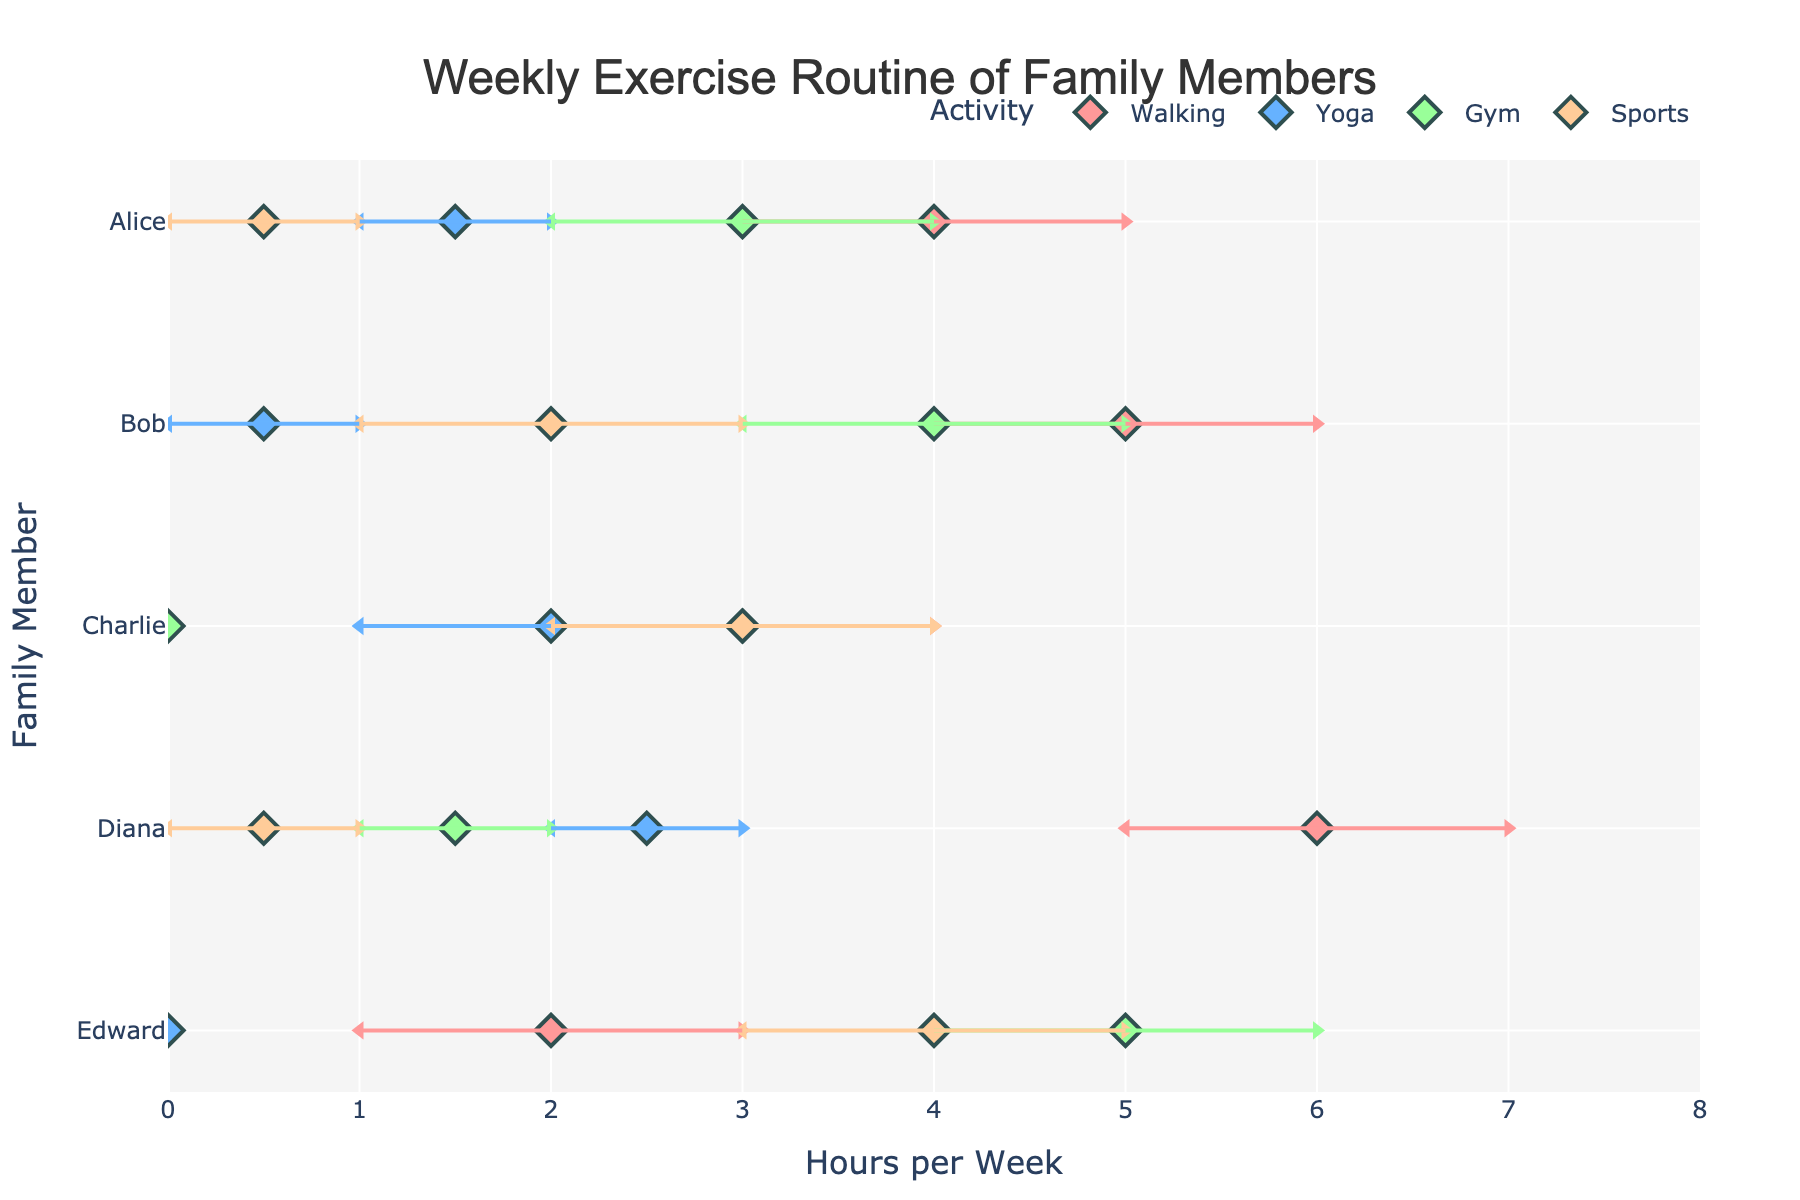What is the title of the figure? The title of the figure is generally displayed at the top center of the plot in a larger font size. It summarizes the contents of the plot.
Answer: Weekly Exercise Routine of Family Members Which family member spends the most hours walking? Look for the family member with the highest value in the range for the "Walking" activity. This means comparing the maximum hours for walking among all family members.
Answer: Diana Who spends more time on sports, Charlie or Edward? Compare the ranges of hours spent on sports for Charlie and Edward. Charlie's range is 2 to 4 hours, while Edward's range is 3 to 5 hours. Edward has a higher range.
Answer: Edward What is the minimum number of hours per week that Diana spends on yoga? Look at Diana's data for the yoga activity and find the minimum value in the given range.
Answer: 2 Which activity is marked with a blue color? Notice the colors used to represent different activities in the plot's legend. Identify which activity corresponds to the blue color.
Answer: Yoga How many activities does Alice participate in? Count the number of distinct activities listed for Alice in the data table.
Answer: 4 Which activities does Edward not participate in? Check Edward's details for activities that have either 0 hours in both min and max columns or are not listed.
Answer: Yoga Who has the highest maximum number of hours for any single activity? Identify the highest maximum hour value among all activities for all family members. Compare these maximum values to find the highest one.
Answer: Diana (Walking, 7 hours) Between Alice and Bob, who spends a wider range of hours at the gym? Compare the range (difference between max and min hours) for the gym activity for both Alice and Bob. For Alice, the range is 4-2=2 hours. For Bob, the range is 5-3=2 hours. Both have the same range.
Answer: Both Alice and Bob 